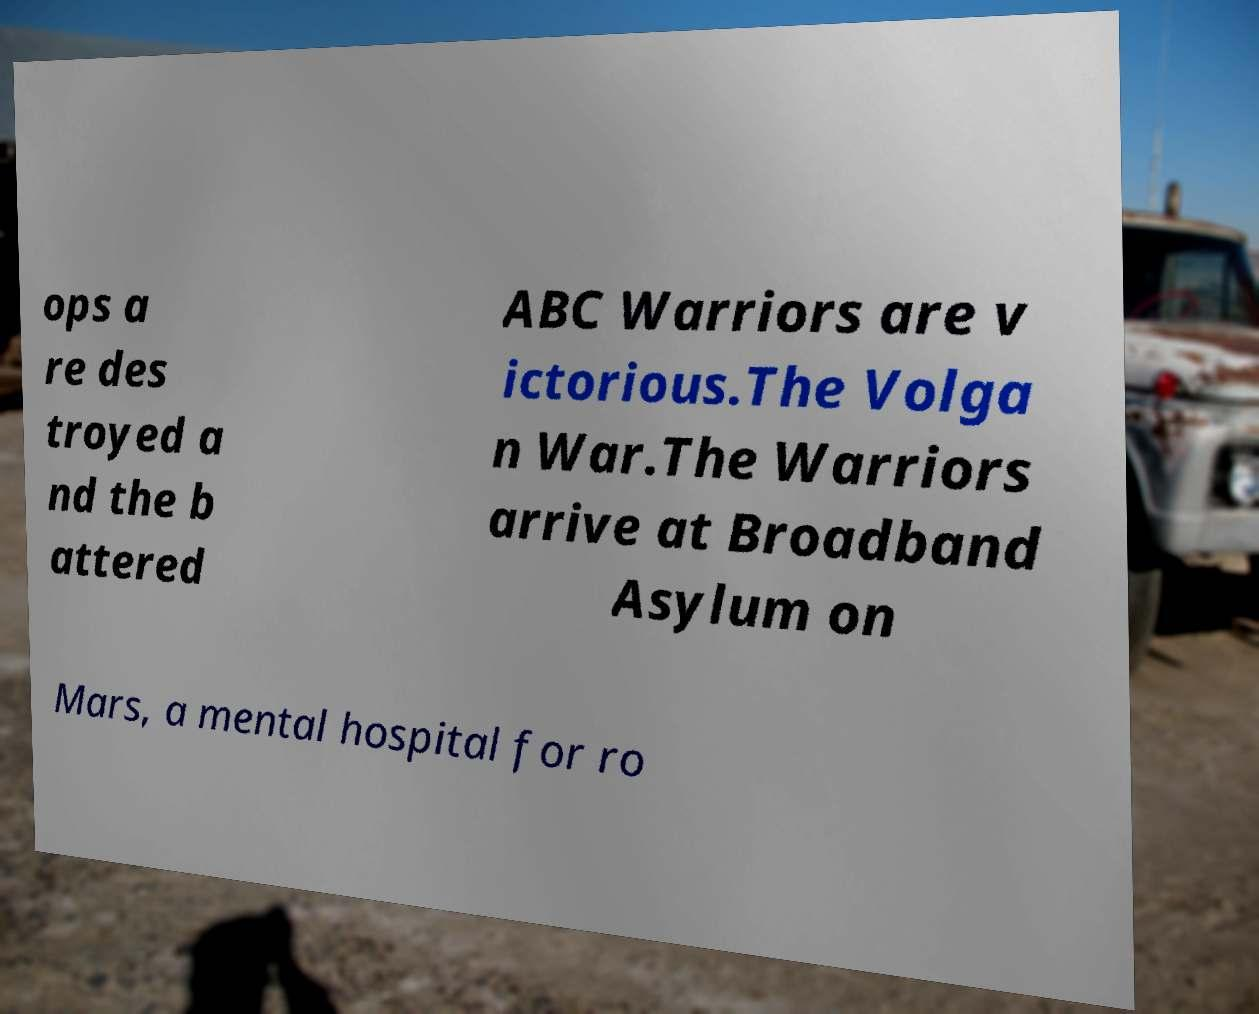Please identify and transcribe the text found in this image. ops a re des troyed a nd the b attered ABC Warriors are v ictorious.The Volga n War.The Warriors arrive at Broadband Asylum on Mars, a mental hospital for ro 